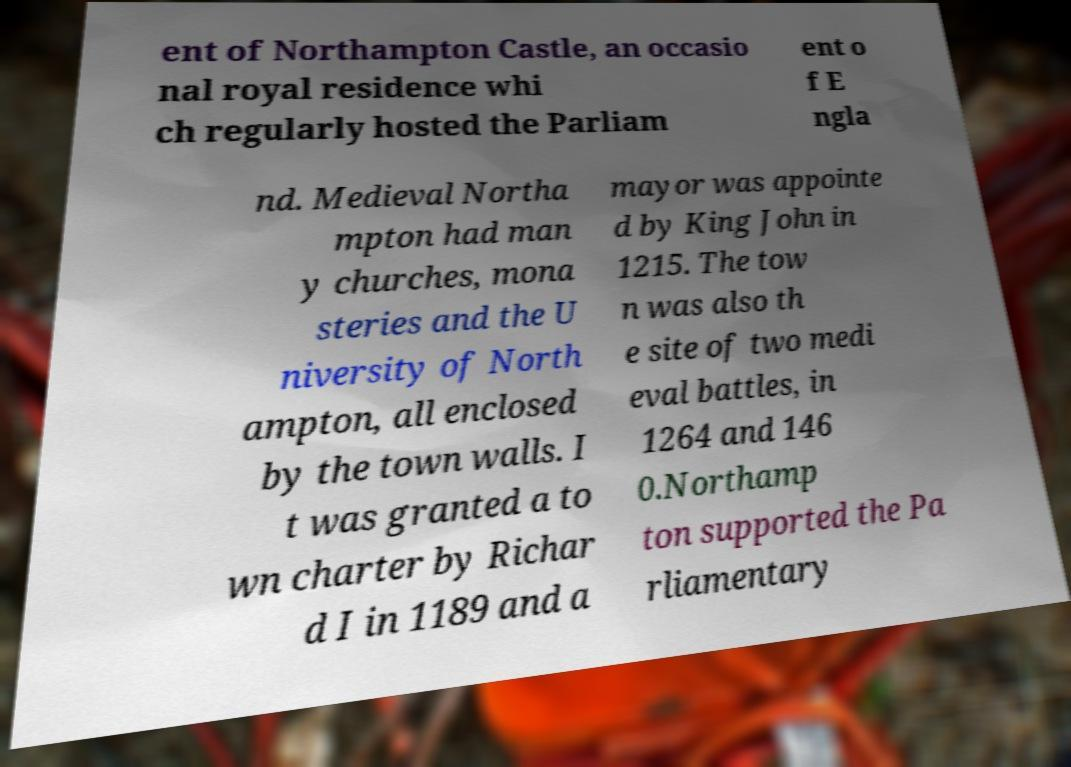I need the written content from this picture converted into text. Can you do that? ent of Northampton Castle, an occasio nal royal residence whi ch regularly hosted the Parliam ent o f E ngla nd. Medieval Northa mpton had man y churches, mona steries and the U niversity of North ampton, all enclosed by the town walls. I t was granted a to wn charter by Richar d I in 1189 and a mayor was appointe d by King John in 1215. The tow n was also th e site of two medi eval battles, in 1264 and 146 0.Northamp ton supported the Pa rliamentary 